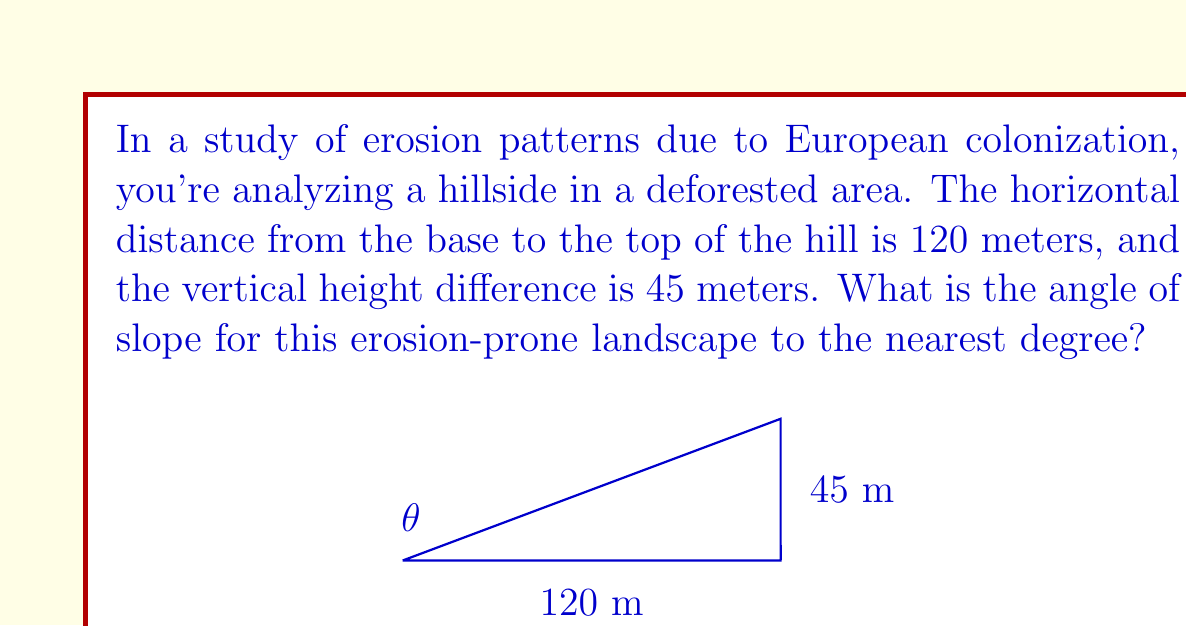Can you answer this question? To determine the angle of slope, we can use trigonometry, specifically the tangent function. Let's approach this step-by-step:

1) In a right triangle formed by the hillside, we know:
   - The opposite side (vertical height) = 45 meters
   - The adjacent side (horizontal distance) = 120 meters

2) The tangent of the angle is the ratio of the opposite side to the adjacent side:

   $$\tan(\theta) = \frac{\text{opposite}}{\text{adjacent}} = \frac{45}{120}$$

3) To find the angle, we need to use the inverse tangent (arctan or $\tan^{-1}$):

   $$\theta = \tan^{-1}\left(\frac{45}{120}\right)$$

4) Using a calculator or computer:

   $$\theta = \tan^{-1}(0.375) \approx 20.556^\circ$$

5) Rounding to the nearest degree:

   $$\theta \approx 21^\circ$$

This angle represents the slope of the erosion-prone landscape, which is crucial for understanding the potential for soil loss and ecological changes due to deforestation associated with European colonization.
Answer: $21^\circ$ 